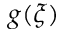Convert formula to latex. <formula><loc_0><loc_0><loc_500><loc_500>g ( \xi )</formula> 